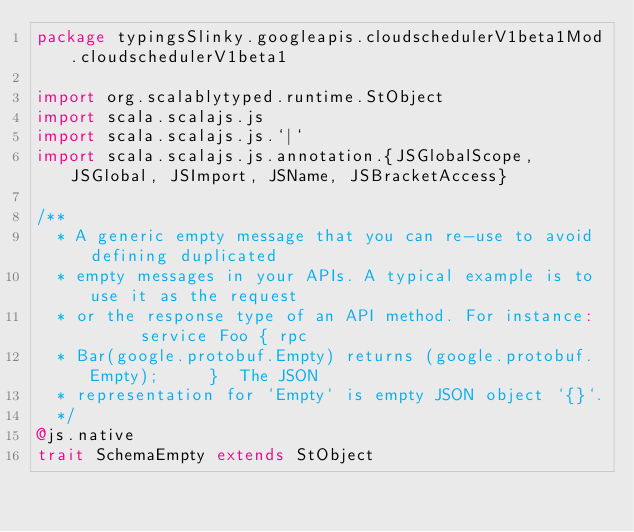<code> <loc_0><loc_0><loc_500><loc_500><_Scala_>package typingsSlinky.googleapis.cloudschedulerV1beta1Mod.cloudschedulerV1beta1

import org.scalablytyped.runtime.StObject
import scala.scalajs.js
import scala.scalajs.js.`|`
import scala.scalajs.js.annotation.{JSGlobalScope, JSGlobal, JSImport, JSName, JSBracketAccess}

/**
  * A generic empty message that you can re-use to avoid defining duplicated
  * empty messages in your APIs. A typical example is to use it as the request
  * or the response type of an API method. For instance:      service Foo { rpc
  * Bar(google.protobuf.Empty) returns (google.protobuf.Empty);     }  The JSON
  * representation for `Empty` is empty JSON object `{}`.
  */
@js.native
trait SchemaEmpty extends StObject
</code> 